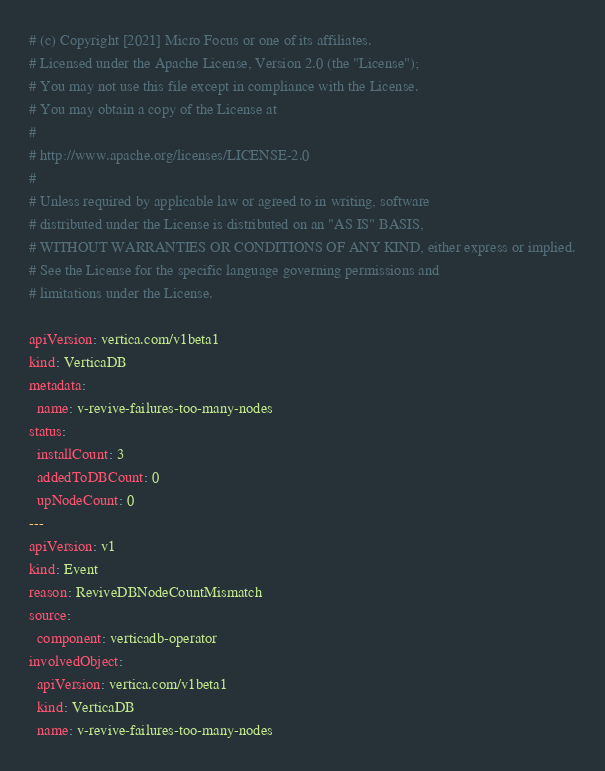Convert code to text. <code><loc_0><loc_0><loc_500><loc_500><_YAML_># (c) Copyright [2021] Micro Focus or one of its affiliates.
# Licensed under the Apache License, Version 2.0 (the "License");
# You may not use this file except in compliance with the License.
# You may obtain a copy of the License at
#
# http://www.apache.org/licenses/LICENSE-2.0
#
# Unless required by applicable law or agreed to in writing, software
# distributed under the License is distributed on an "AS IS" BASIS,
# WITHOUT WARRANTIES OR CONDITIONS OF ANY KIND, either express or implied.
# See the License for the specific language governing permissions and
# limitations under the License.

apiVersion: vertica.com/v1beta1
kind: VerticaDB
metadata:
  name: v-revive-failures-too-many-nodes
status:
  installCount: 3
  addedToDBCount: 0
  upNodeCount: 0
---
apiVersion: v1
kind: Event
reason: ReviveDBNodeCountMismatch
source:
  component: verticadb-operator
involvedObject:
  apiVersion: vertica.com/v1beta1
  kind: VerticaDB
  name: v-revive-failures-too-many-nodes
</code> 